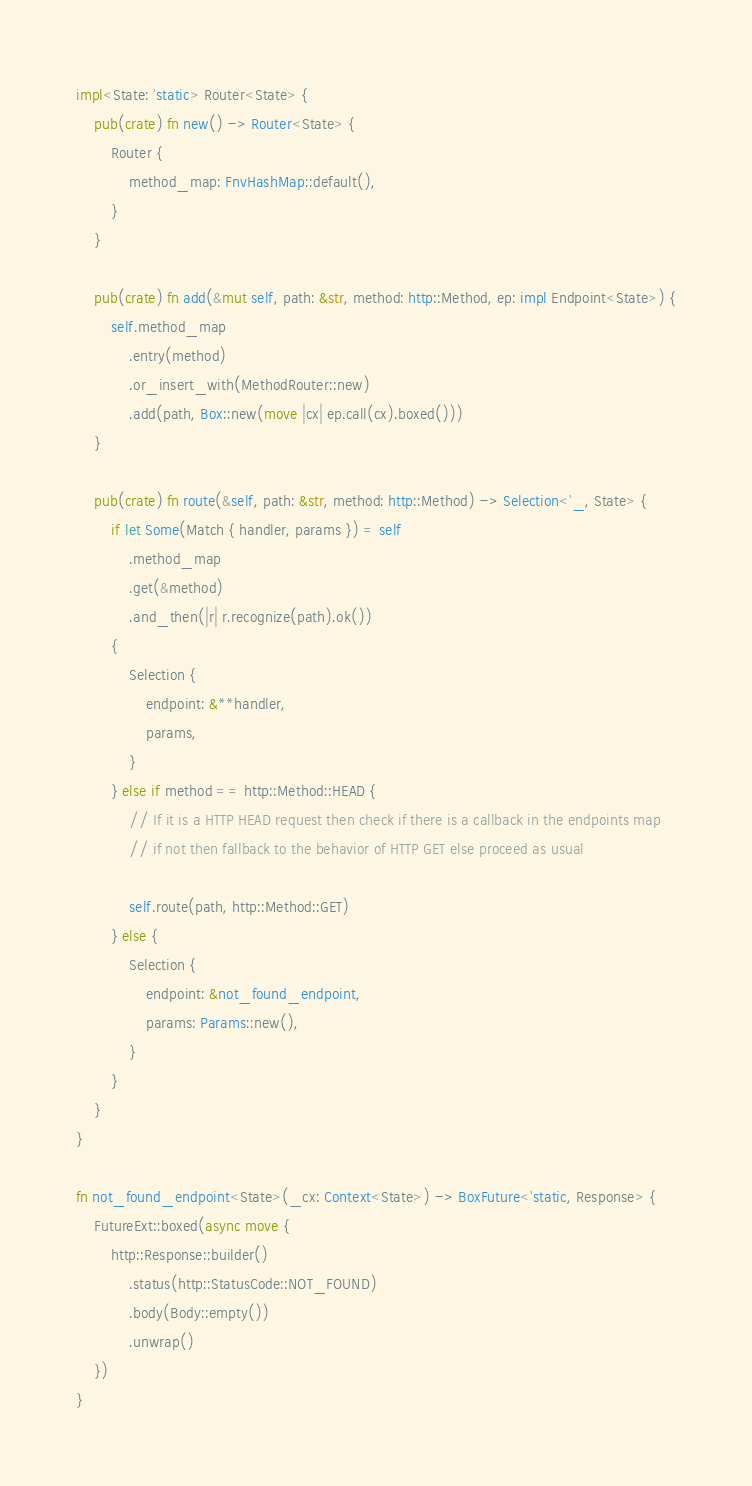Convert code to text. <code><loc_0><loc_0><loc_500><loc_500><_Rust_>
impl<State: 'static> Router<State> {
    pub(crate) fn new() -> Router<State> {
        Router {
            method_map: FnvHashMap::default(),
        }
    }

    pub(crate) fn add(&mut self, path: &str, method: http::Method, ep: impl Endpoint<State>) {
        self.method_map
            .entry(method)
            .or_insert_with(MethodRouter::new)
            .add(path, Box::new(move |cx| ep.call(cx).boxed()))
    }

    pub(crate) fn route(&self, path: &str, method: http::Method) -> Selection<'_, State> {
        if let Some(Match { handler, params }) = self
            .method_map
            .get(&method)
            .and_then(|r| r.recognize(path).ok())
        {
            Selection {
                endpoint: &**handler,
                params,
            }
        } else if method == http::Method::HEAD {
            // If it is a HTTP HEAD request then check if there is a callback in the endpoints map
            // if not then fallback to the behavior of HTTP GET else proceed as usual

            self.route(path, http::Method::GET)
        } else {
            Selection {
                endpoint: &not_found_endpoint,
                params: Params::new(),
            }
        }
    }
}

fn not_found_endpoint<State>(_cx: Context<State>) -> BoxFuture<'static, Response> {
    FutureExt::boxed(async move {
        http::Response::builder()
            .status(http::StatusCode::NOT_FOUND)
            .body(Body::empty())
            .unwrap()
    })
}
</code> 